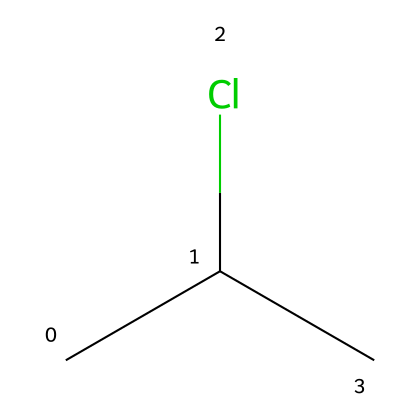What is the molecular formula for this structure? The chemical structure represents a compound with three carbon atoms, several hydrogen atoms, and one chlorine atom. The general molecular formula for compounds with this structure can be summarized as C3H7Cl.
Answer: C3H7Cl How many carbon atoms are in this chemical? The SMILES representation shows three "C" atoms corresponding to carbon. Therefore, the count of carbon atoms is three.
Answer: three What type of bonding is primarily present in this chemical? The chemical consists of covalent bonds among carbon, hydrogen, and chlorine atoms as indicated by the absence of charge and the nature of the atom connections.
Answer: covalent Does this chemical contain chlorine? The "Cl" in the SMILES structure indicates the presence of a chlorine atom in the compound.
Answer: yes What is the primary use of this type of chemical in construction? This chemical structure, representative of polyvinyl chloride (PVC), is predominantly used in window frames and plumbing due to its durability and resistance to moisture.
Answer: window frames and plumbing How many hydrogen atoms are there in this structure? Each of the carbon atoms is generally saturated with hydrogen, and considering the presence of chlorine, the total is seven (3 carbon atoms maxing out at 7, minus the effect of Cl). Thus, there are seven hydrogen atoms.
Answer: seven Is this structure polar or nonpolar? The presence of chlorine, which is more electronegative than carbon and hydrogen, creates a dipole moment, indicating that the overall molecule is polar.
Answer: polar 